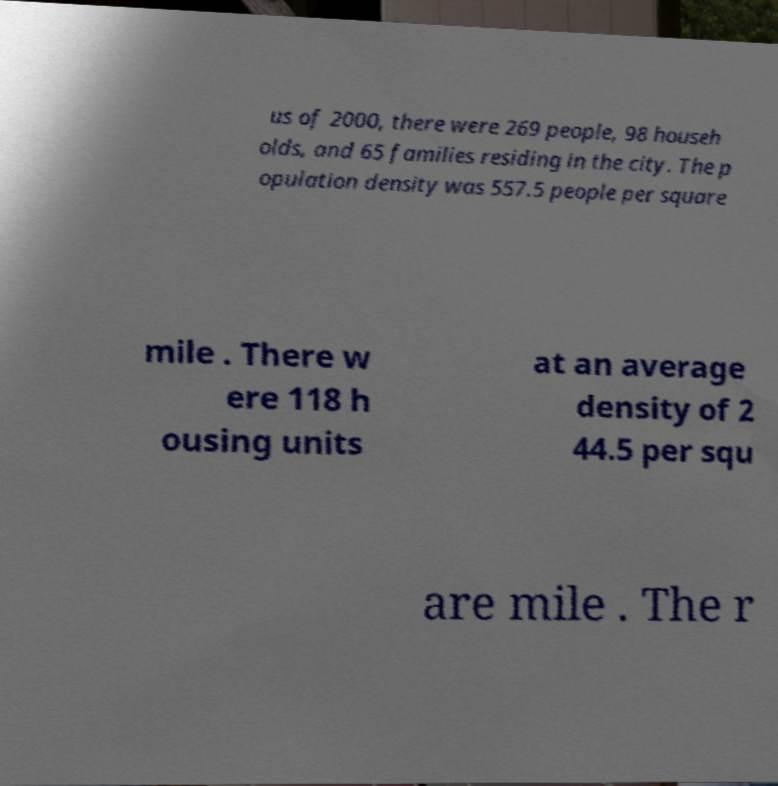Could you assist in decoding the text presented in this image and type it out clearly? us of 2000, there were 269 people, 98 househ olds, and 65 families residing in the city. The p opulation density was 557.5 people per square mile . There w ere 118 h ousing units at an average density of 2 44.5 per squ are mile . The r 